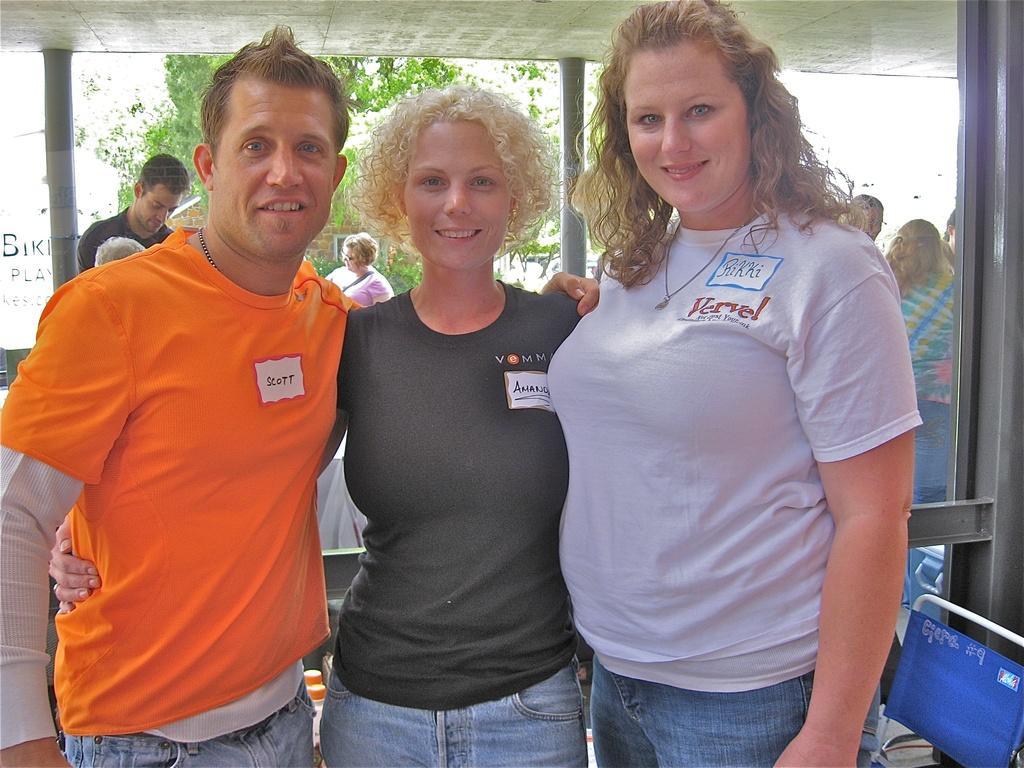In one or two sentences, can you explain what this image depicts? In this picture I can see three persons standing, there is a chair, there are group of people standing, there are pillars, and in the background there are trees. 